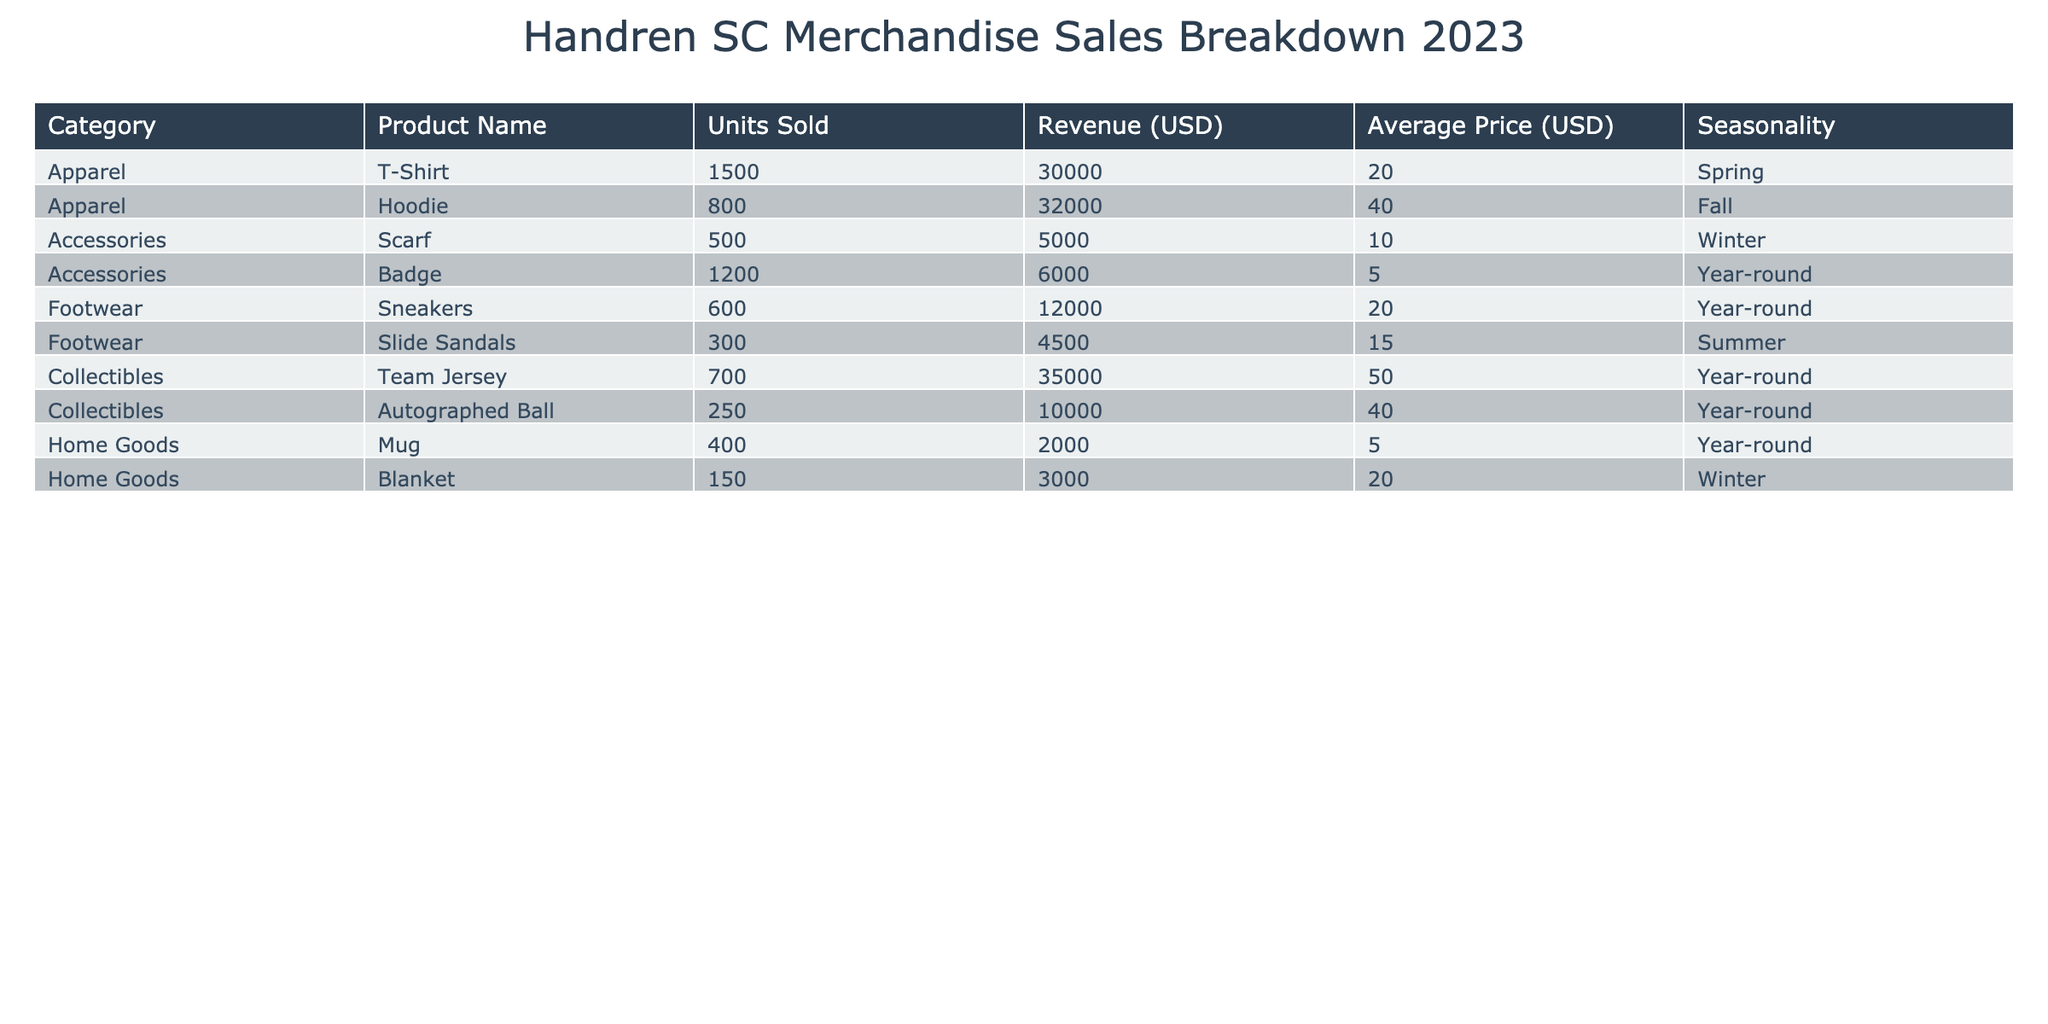What is the total revenue generated from merchandise sales? To find the total revenue, sum the revenue of all products: 30,000 (T-Shirt) + 32,000 (Hoodie) + 5,000 (Scarf) + 6,000 (Badge) + 12,000 (Sneakers) + 4,500 (Slide Sandals) + 35,000 (Team Jersey) + 10,000 (Autographed Ball) + 2,000 (Mug) + 3,000 (Blanket) = 129,500.
Answer: 129,500 Which category had the highest revenue in 2023? To determine the highest revenue category, compare the total revenues for each category: Apparel: 62,000; Accessories: 11,000; Footwear: 16,500; Collectibles: 45,000; Home Goods: 5,000. The highest is Apparel at 62,000.
Answer: Apparel How many units of Team Jerseys were sold? There were 700 units of Team Jerseys sold as listed in the table under the Collectibles category.
Answer: 700 What is the average price of footwear products? To find the average price of footwear, calculate the sum of the average prices of Sneakers and Slide Sandals: (20 + 15) = 35. Then divide by the number of footwear products, which is 2: 35 / 2 = 17.5.
Answer: 17.5 Are more than 1000 badges sold? According to the table, 1200 badges were sold, which is greater than 1000, making this statement true.
Answer: Yes What is the seasonality for the highest sold apparel item? The highest sold apparel item is the T-Shirt, with 1500 units sold. Its seasonality is Spring.
Answer: Spring What is the total number of units sold across all categories? To find the total number of units sold, sum the units sold for each product: 1500 (T-Shirt) + 800 (Hoodie) + 500 (Scarf) + 1200 (Badge) + 600 (Sneakers) + 300 (Slide Sandals) + 700 (Team Jersey) + 250 (Autographed Ball) + 400 (Mug) + 150 (Blanket) = 5500.
Answer: 5500 How much revenue is generated by accessories in total? The total revenue from accessories is the sum of the revenue from Scarf and Badge: 5,000 (Scarf) + 6,000 (Badge) = 11,000.
Answer: 11,000 Is the average price of a hoodie greater than the average price of a T-Shirt? The average price of a hoodie is 40, while the average price of a T-Shirt is 20. Since 40 is greater than 20, the statement is true.
Answer: Yes 